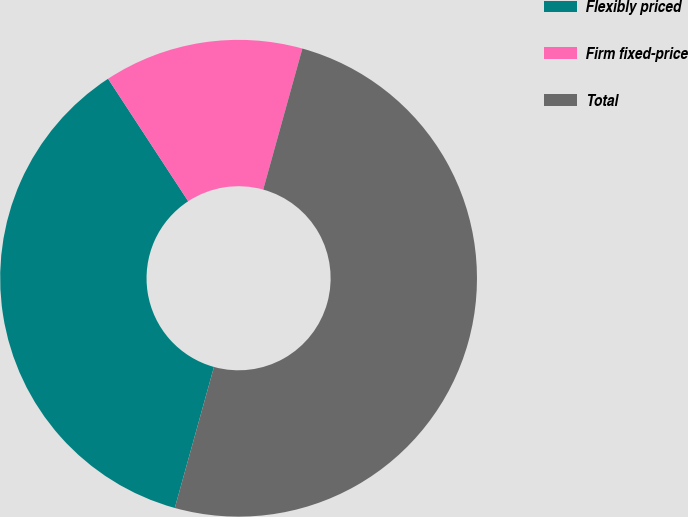<chart> <loc_0><loc_0><loc_500><loc_500><pie_chart><fcel>Flexibly priced<fcel>Firm fixed-price<fcel>Total<nl><fcel>36.47%<fcel>13.53%<fcel>50.0%<nl></chart> 